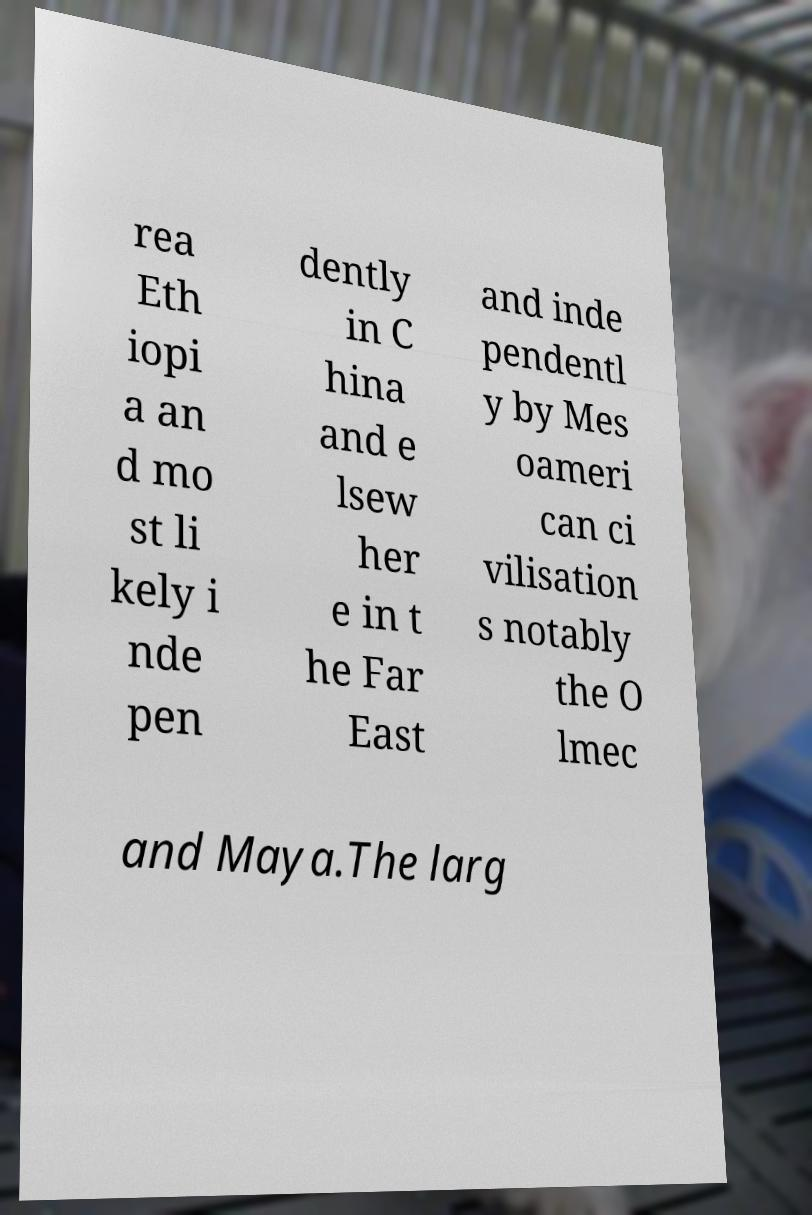There's text embedded in this image that I need extracted. Can you transcribe it verbatim? rea Eth iopi a an d mo st li kely i nde pen dently in C hina and e lsew her e in t he Far East and inde pendentl y by Mes oameri can ci vilisation s notably the O lmec and Maya.The larg 